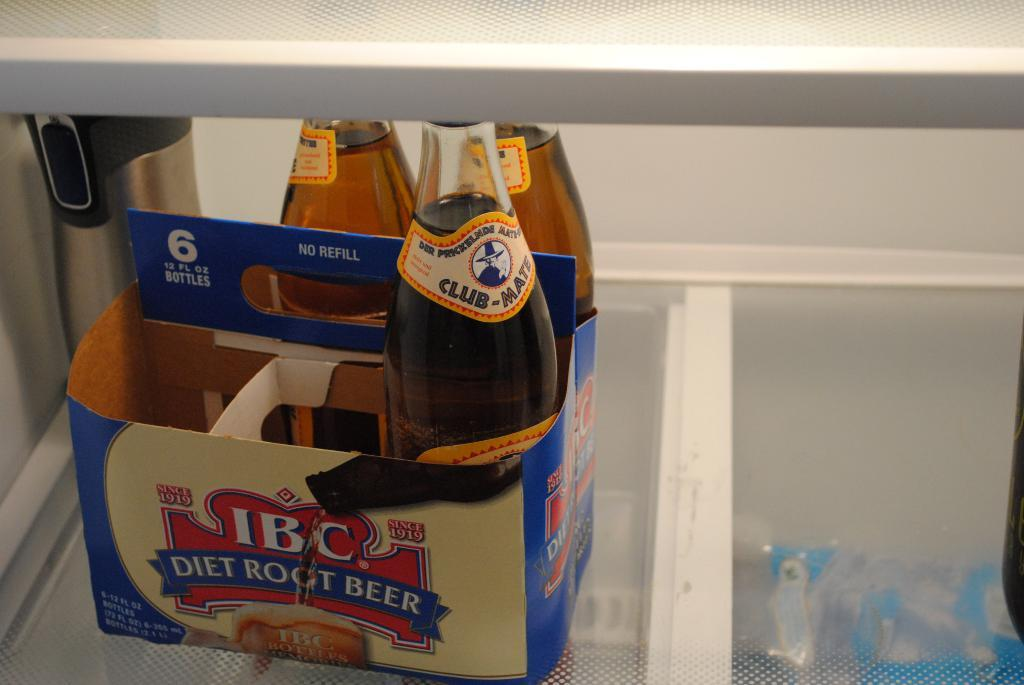<image>
Relay a brief, clear account of the picture shown. the letters IBC are on the items of root beer 